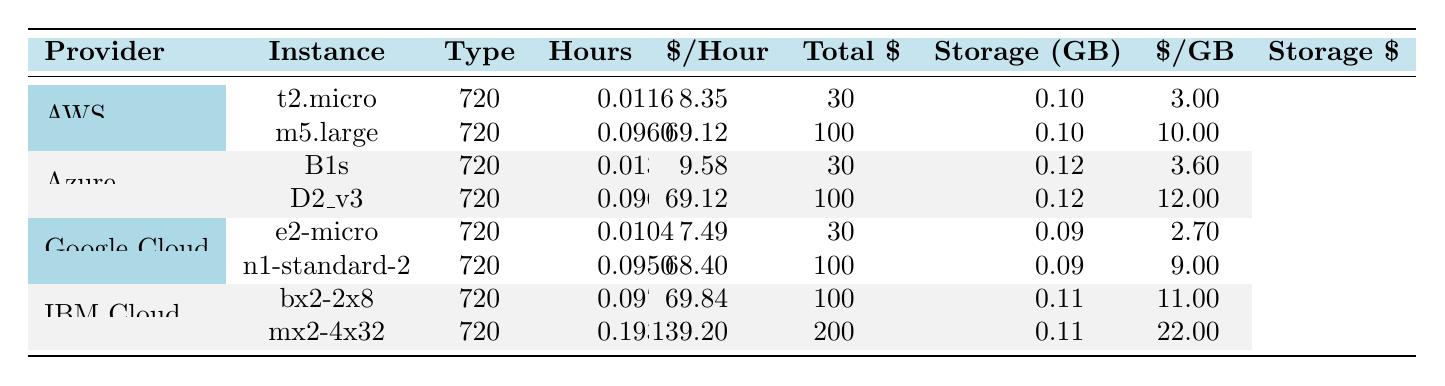What is the total cost of the t2.micro instance from AWS? The total cost of the t2.micro instance from AWS is directly listed in the table under the "Total $" column, which states it is 8.35.
Answer: 8.35 Which provider has the most expensive instance type? To find the most expensive instance type, we can look at the "Total $" column across all providers. The mx2-4x32 from IBM Cloud has a total cost of 139.20, which is higher than all others listed.
Answer: IBM Cloud How much is the storage cost for the D2_v3 instance from Azure? The storage cost for the D2_v3 instance is given in the table under the "Storage \$" column, which shows it is 12.00.
Answer: 12.00 What is the average cost per hour of all instance types listed? The hourly costs per instance type are: 0.0116, 0.096, 0.0133, 0.096, 0.0104, 0.095, 0.097, and 0.193. We sum these values: (0.0116 + 0.096 + 0.0133 + 0.096 + 0.0104 + 0.095 + 0.097 + 0.193) = 0.6223. There are 8 instance types, so the average is 0.6223 / 8 = 0.07779.
Answer: 0.07779 Is the storage cost per GB higher for Google Cloud or AWS? For Google Cloud, the storage cost per GB is 0.09 and for AWS, it is 0.10. Since 0.10 > 0.09, the storage cost is higher for AWS than Google Cloud.
Answer: No What is the total combined cost (total cost + storage cost) for the m5.large instance from AWS? The total cost for the m5.large instance is 69.12, and the total storage cost is 10.00. Adding these together gives: 69.12 + 10.00 = 79.12.
Answer: 79.12 Which provider offers the cheapest overall cost for a VM instance with 30GB of storage? By comparing instances with 30GB of storage, we find the t2.micro from AWS costs 8.35, the B1s from Azure costs 9.58, and the e2-micro from Google Cloud costs 7.49. The cheapest is the e2-micro from Google Cloud.
Answer: Google Cloud How much less does the e2-micro instance from Google Cloud cost compared to the t2.micro instance from AWS? The total cost for the e2-micro instance is 7.49 and the t2.micro is 8.35. The difference is 8.35 - 7.49 = 0.86.
Answer: 0.86 